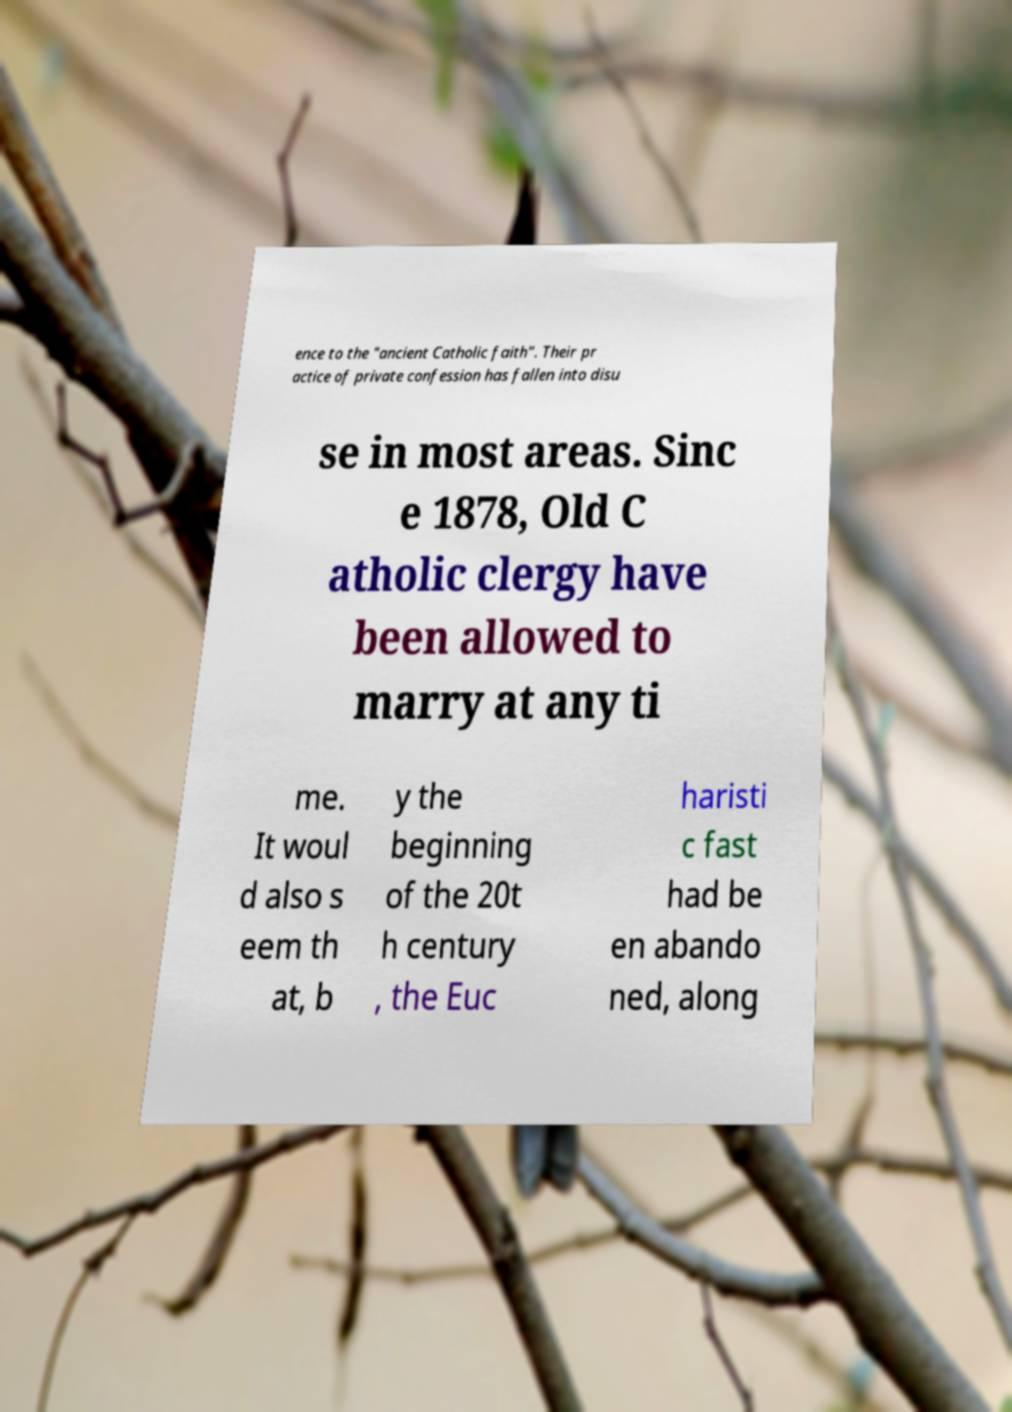What messages or text are displayed in this image? I need them in a readable, typed format. ence to the "ancient Catholic faith". Their pr actice of private confession has fallen into disu se in most areas. Sinc e 1878, Old C atholic clergy have been allowed to marry at any ti me. It woul d also s eem th at, b y the beginning of the 20t h century , the Euc haristi c fast had be en abando ned, along 